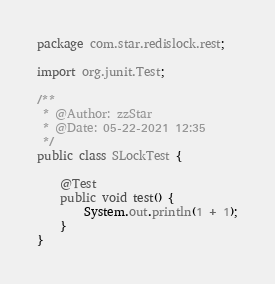<code> <loc_0><loc_0><loc_500><loc_500><_Java_>package com.star.redislock.rest;

import org.junit.Test;

/**
 * @Author: zzStar
 * @Date: 05-22-2021 12:35
 */
public class SLockTest {

    @Test
    public void test() {
        System.out.println(1 + 1);
    }
}
</code> 